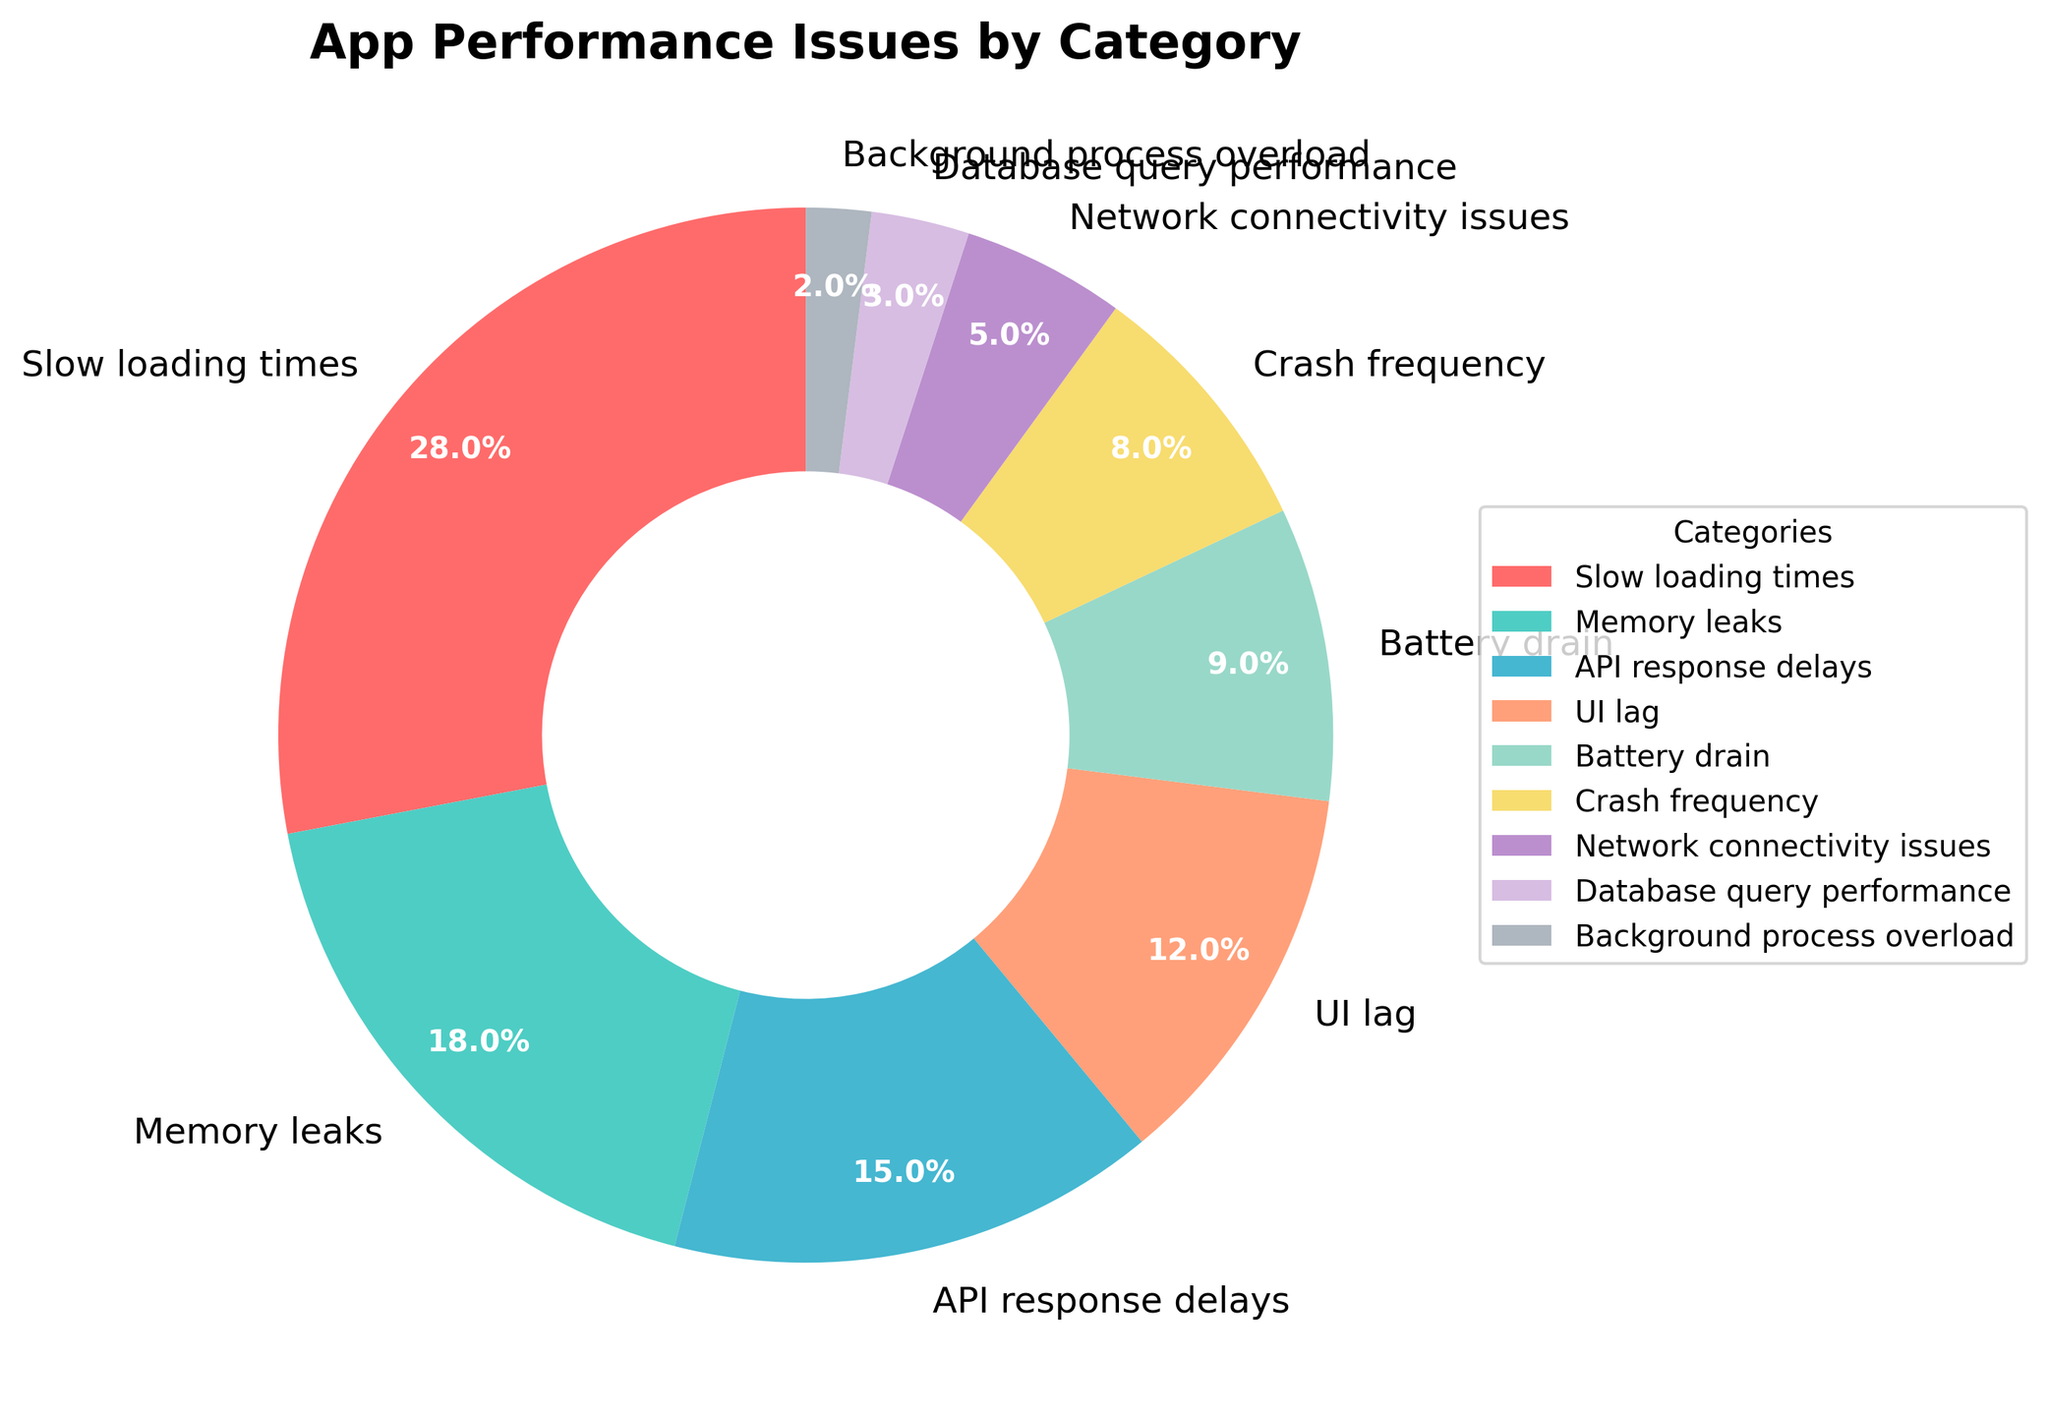what's the total percentage of "Slow loading times" and "Memory leaks"? Add the percentages of "Slow loading times" (28%) and "Memory leaks" (18%). So, 28 + 18 = 46%.
Answer: 46% Which category has the highest percentage? The category with the highest percentage is the one with the largest pie slice. "Slow loading times" has the highest percentage at 28%.
Answer: "Slow loading times" What's the difference in percentage between "API response delays" and "Crash frequency"? Subtract the percentage of "Crash frequency" (8%) from "API response delays" (15%). So, 15 - 8 = 7.
Answer: 7% Which category appears between "Battery drain" and "Memory leaks" based on the slice order in the pie chart? "API response delays" is the category that comes between "Memory leaks" and "Battery drain" in terms of the slice order in the pie chart.
Answer: "API response delays" What is the combined percentage of all categories that have a percentage of 10% or less? Add the percentages of categories with 10% or less: UI lag (12% not included), Battery drain (9%), Crash frequency (8%), Network connectivity issues (5%), Database query performance (3%), and Background process overload (2%). So, 9 + 8 + 5 + 3 + 2 = 27%.
Answer: 27% What color is used to represent the "UI lag" category on the pie chart? The "UI lag" category's color in the pie chart is visually identified by its wedge color. It is represented in "orange" (as described in the code by '#FFA07A').
Answer: orange Which has a larger percentage: "Battery drain" or "Network connectivity issues"? Compare the percentages. "Battery drain" has 9%, while "Network connectivity issues" has 5%, so "Battery drain" has a larger percentage.
Answer: "Battery drain" What is the second least common performance issue shown in the pie chart? The second least common issue, given the performance categories listed in ascending order, is "Background process overload" at 2% (with "Database query performance" at 3% being the least).
Answer: "Background process overload" By how much percent is "Crash frequency" lower than "Slow loading times"? Subtract "Crash frequency" (8%) from "Slow loading times" (28%). So, 28 - 8 = 20%.
Answer: 20% How many categories have a wedge size under 10%? Count the number of categories with percentages less than 10%: Battery drain (9%), Crash frequency (8%), Network connectivity issues (5%), Database query performance (3%), Background process overload (2%). This gives 5 categories.
Answer: 5 